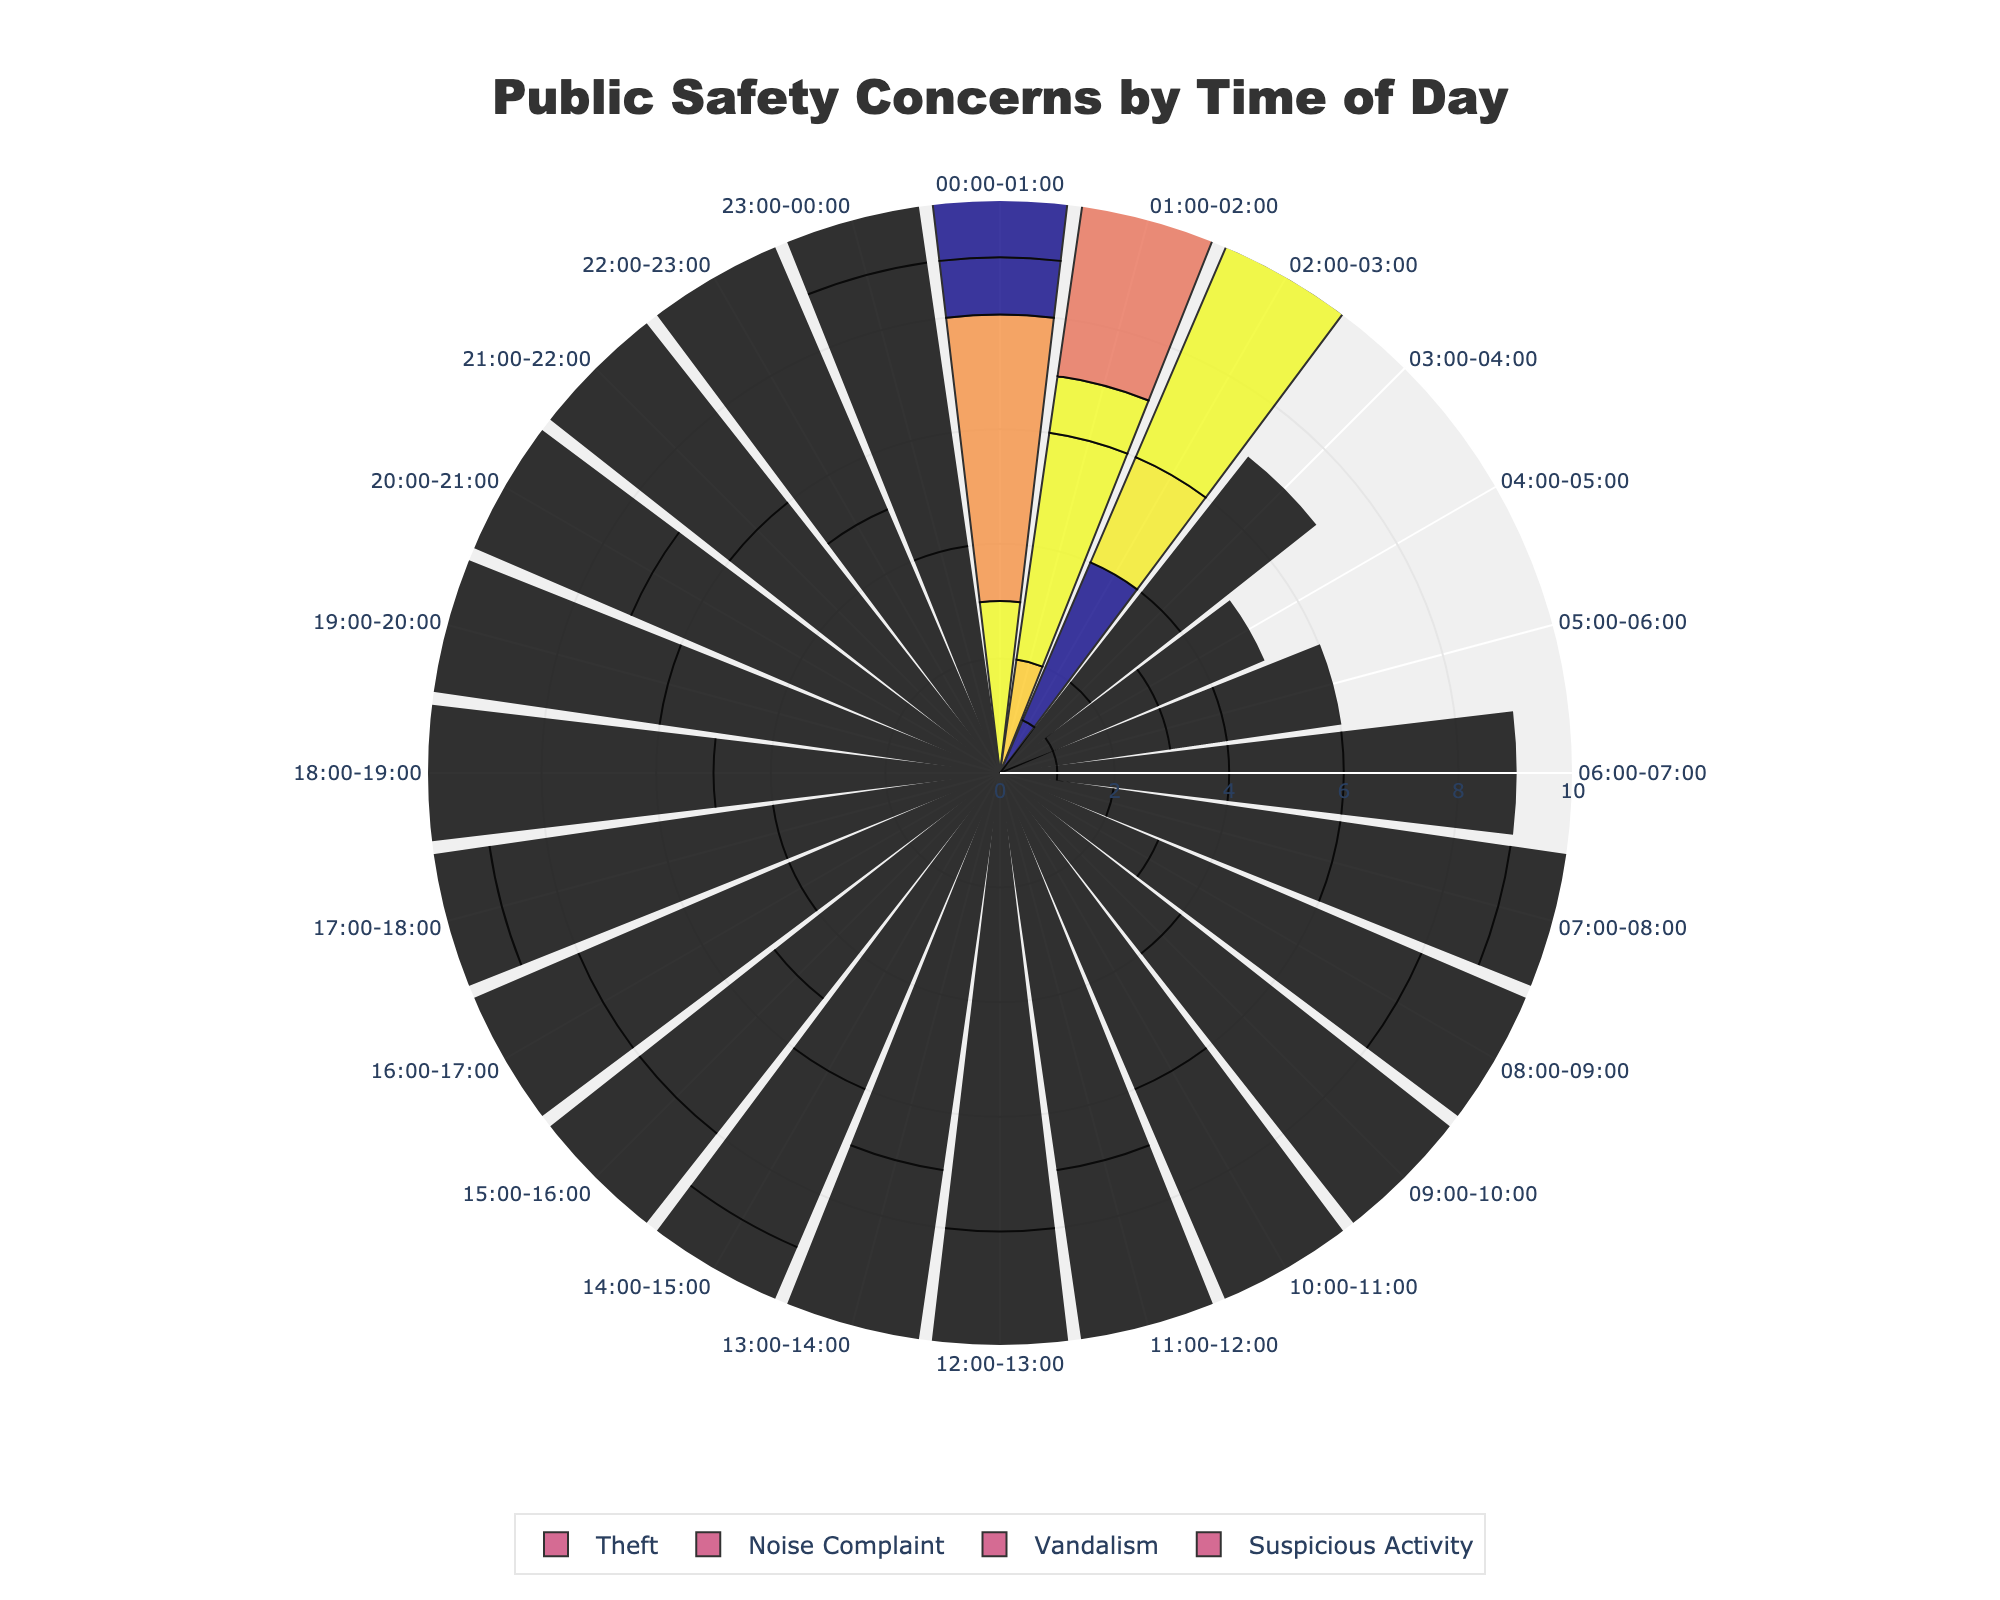What is the title of the chart? The title is the text placed at the top center of the chart.
Answer: Public Safety Concerns by Time of Day How many reports of vandalism were there between 20:00-21:00? Check the data corresponding to Vandalism and the time interval 20:00-21:00.
Answer: 6 Which category had the highest number of reports during 12:00-13:00? Compare the number of reports for each category during 12:00-13:00.
Answer: Theft What is the number of reports for Noise Complaints and Vandalism combined at 07:00-08:00? Add the number of reports for Noise Complaints and Vandalism at 07:00-08:00.
Answer: 7 During which time slot did the reports of Suspicious Activity peak? Identify the time slot with the maximum number of reports for Suspicious Activity.
Answer: 18:00-19:00 Is there any time slot where reports of Theft, Noise Complaints, Vandalism, and Suspicious Activity are all less than 5? Check each time slot and confirm if any time slot meets the condition.
Answer: No How does the pattern of reports for Noise Complaints change over the day? Observe the trend of the number of reports for Noise Complaints from 00:00-01:00 to 23:00-00:00.
Answer: Increase in the morning, peak in the evening Which category has the lowest variability in the number of reports throughout the day? Compare the range (difference between max and min reports) for each category.
Answer: Vandalism Comparatively, did Theft or Suspicious Activity have more reports during 10:00-11:00? Compare the number of reports for Theft and Suspicious Activity during 10:00-11:00.
Answer: Theft During which time intervals do Noise Complaint reports peak? Identify the time intervals with the highest number of Noise Complaint reports.
Answer: 20:00-21:00 